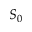Convert formula to latex. <formula><loc_0><loc_0><loc_500><loc_500>S _ { 0 }</formula> 